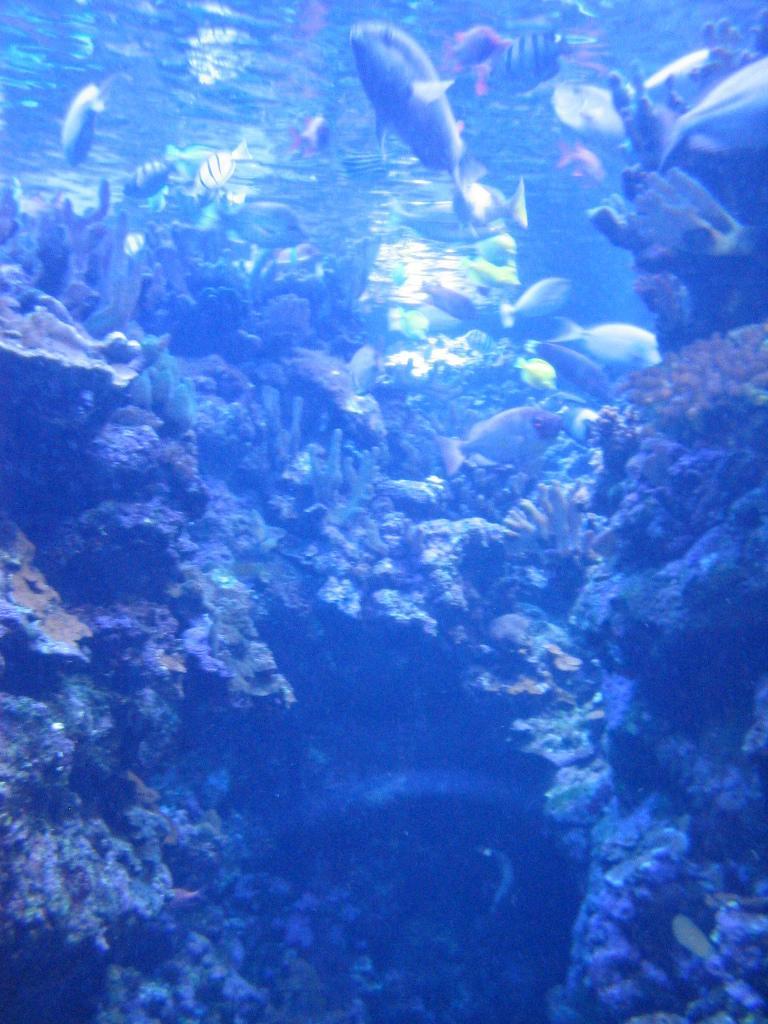In one or two sentences, can you explain what this image depicts? In this picture I can see fishes and corals under the water. 